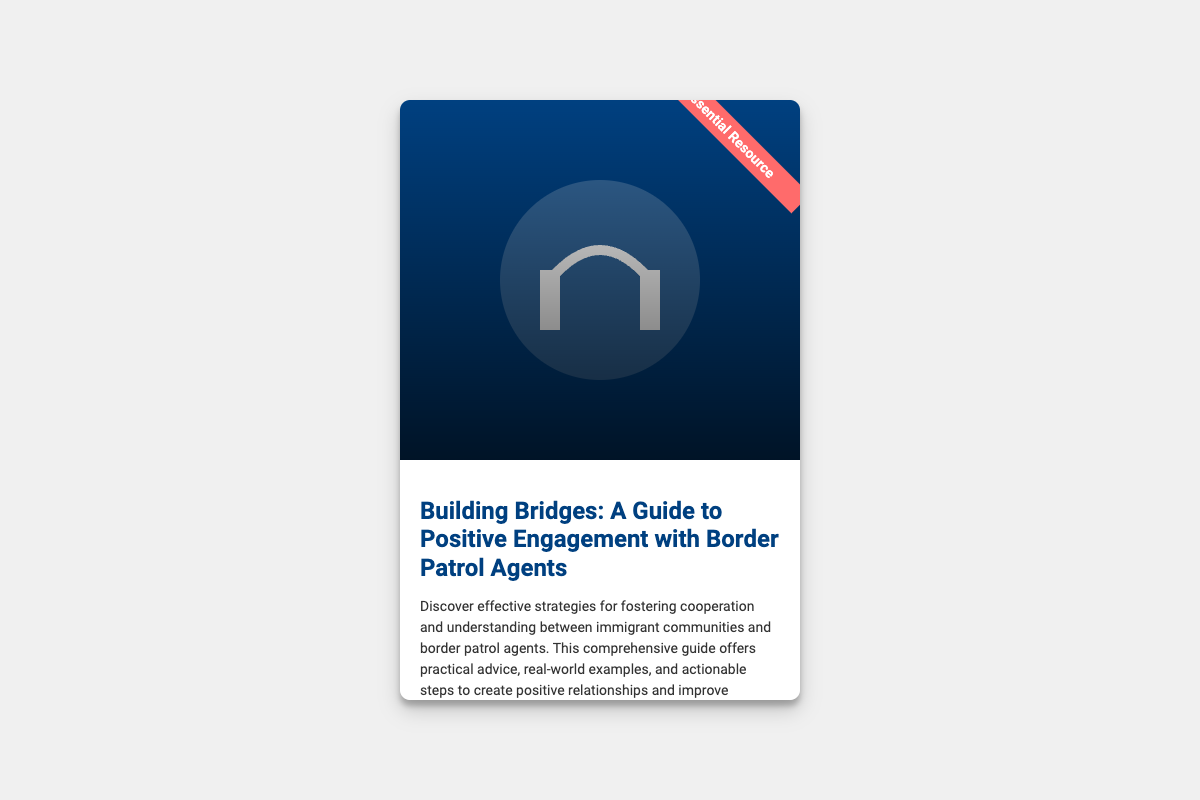What is the title of the book? The title of the book is prominently displayed at the top of the cover, which is "Building Bridges: A Guide to Positive Engagement with Border Patrol Agents."
Answer: Building Bridges: A Guide to Positive Engagement with Border Patrol Agents Who is the author of the book? The author's name appears in italics at the bottom of the book information section, indicating their expertise in the subject matter.
Answer: An Immigrant Advocacy Expert What is the primary focus of the book? The book description explains that it offers strategies for fostering cooperation and understanding between immigrant communities and border patrol agents.
Answer: Fostering cooperation and understanding What color is the ribbon on the book cover? The ribbon on the cover has a specific color mentioned in the description, which is used to draw attention to its significance.
Answer: Red What type of imagery is featured on the cover? The cover features an image symbolizing partnership and cooperation, specifically showing a handshake at a border fence.
Answer: Handshake at a border fence What does the cover suggest about the book's target audience? The book's content is aimed at those interested in improving relationships between immigrant communities and border patrol agents, as indicated in the description.
Answer: Immigrant communities and border patrol agents What is the dimension of the book cover represented in the code? The code specifies the width and height of the book cover section, offering a visual representation of its size.
Answer: 400px by 600px What does the gradient overlay on the cover offer? The gradient overlay mentioned in the document provides a visual effect that emphasizes the content on the cover while adding depth.
Answer: Depth and emphasis 